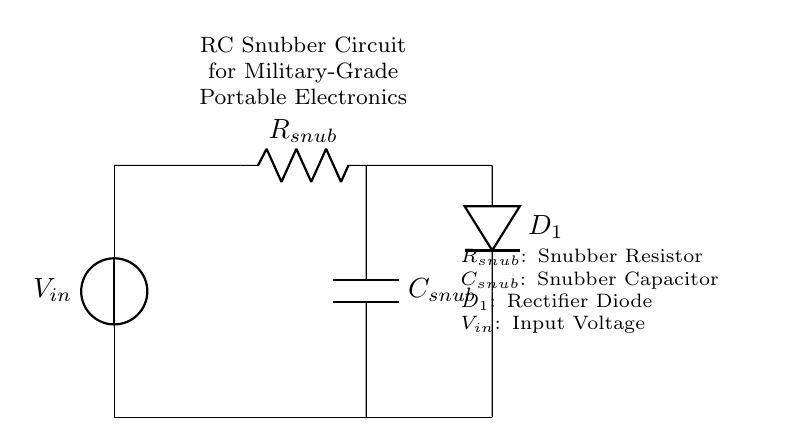What is the input voltage in this circuit? The input voltage is denoted as V_{in}, which is shown at the top of the circuit diagram as the voltage source.
Answer: V_{in} What component is labeled as R_{snub}? The component R_{snub} is identified on the circuit diagram as the resistor connected in series after the input voltage source, which helps in snubbing voltage spikes.
Answer: Resistor What type of diode is used in this circuit? The diode labeled D_{1} is a rectifier diode, which is shown in the circuit to manage voltage directionality and protect against reverse polarity.
Answer: Rectifier diode Explain the role of the capacitor in this circuit. The capacitor C_{snub} is used for filtering out voltage spikes and smoothing the output voltage. It's located parallel to the resistor and serves to absorb transient voltages, thus improving stability.
Answer: Filtering voltage spikes How does the snubber circuit improve the reliability of military-grade electronics? The RC snubber circuit reduces voltage spikes and transients that can occur during operation, thus protecting sensitive components from damage and improving overall reliability and performance in rugged environments.
Answer: Reduces voltage spikes What happens to the energy stored in the capacitor when the input voltage drops? When the input voltage drops, the stored energy in the capacitor is released, helping to maintain a stable output voltage for a short duration, thus supporting the circuit during unexpected voltage fluctuations.
Answer: Stabilizes output voltage What is the primary purpose of the snubber circuit in power supplies? The primary purpose of the snubber circuit is to dampen voltage transients and protect the downstream components from stress caused by rapid changes in voltage.
Answer: Dampen voltage transients 